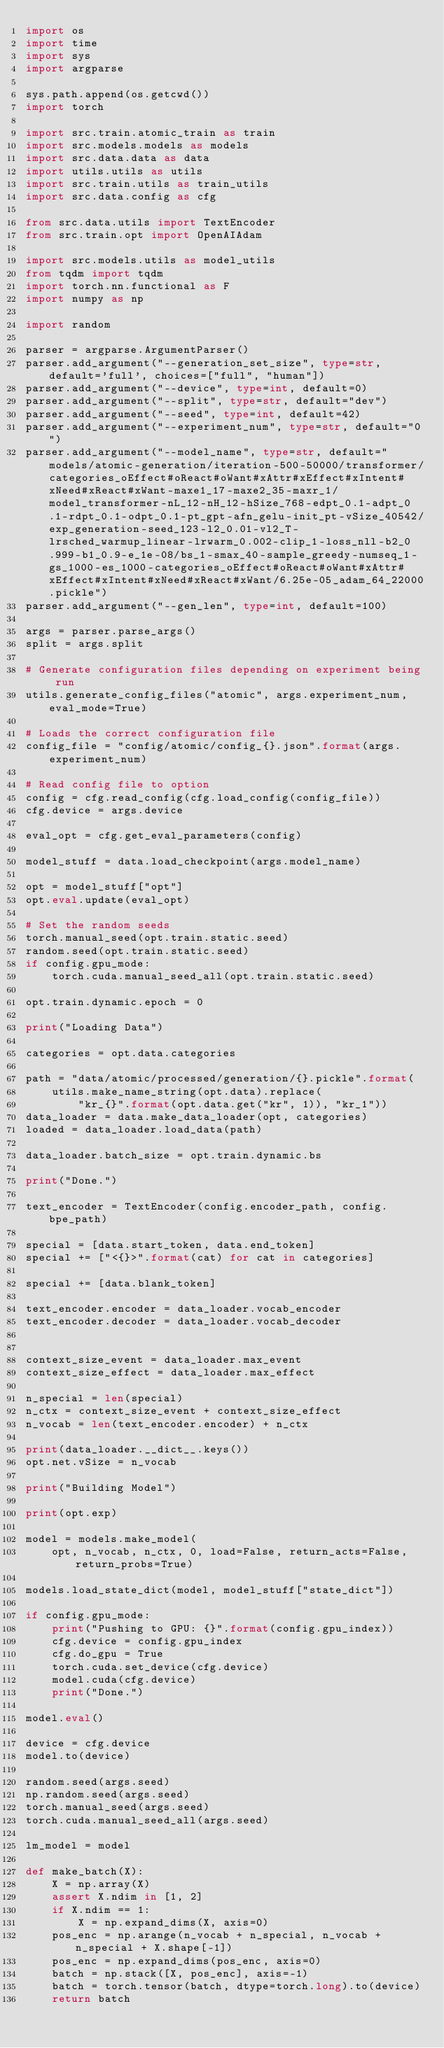<code> <loc_0><loc_0><loc_500><loc_500><_Python_>import os
import time
import sys
import argparse

sys.path.append(os.getcwd())
import torch

import src.train.atomic_train as train
import src.models.models as models
import src.data.data as data
import utils.utils as utils
import src.train.utils as train_utils
import src.data.config as cfg

from src.data.utils import TextEncoder
from src.train.opt import OpenAIAdam

import src.models.utils as model_utils
from tqdm import tqdm
import torch.nn.functional as F
import numpy as np

import random

parser = argparse.ArgumentParser()
parser.add_argument("--generation_set_size", type=str, default='full', choices=["full", "human"])
parser.add_argument("--device", type=int, default=0)
parser.add_argument("--split", type=str, default="dev")
parser.add_argument("--seed", type=int, default=42)
parser.add_argument("--experiment_num", type=str, default="0")
parser.add_argument("--model_name", type=str, default="models/atomic-generation/iteration-500-50000/transformer/categories_oEffect#oReact#oWant#xAttr#xEffect#xIntent#xNeed#xReact#xWant-maxe1_17-maxe2_35-maxr_1/model_transformer-nL_12-nH_12-hSize_768-edpt_0.1-adpt_0.1-rdpt_0.1-odpt_0.1-pt_gpt-afn_gelu-init_pt-vSize_40542/exp_generation-seed_123-l2_0.01-vl2_T-lrsched_warmup_linear-lrwarm_0.002-clip_1-loss_nll-b2_0.999-b1_0.9-e_1e-08/bs_1-smax_40-sample_greedy-numseq_1-gs_1000-es_1000-categories_oEffect#oReact#oWant#xAttr#xEffect#xIntent#xNeed#xReact#xWant/6.25e-05_adam_64_22000.pickle")
parser.add_argument("--gen_len", type=int, default=100)

args = parser.parse_args()
split = args.split

# Generate configuration files depending on experiment being run
utils.generate_config_files("atomic", args.experiment_num, eval_mode=True)

# Loads the correct configuration file
config_file = "config/atomic/config_{}.json".format(args.experiment_num)

# Read config file to option
config = cfg.read_config(cfg.load_config(config_file))
cfg.device = args.device

eval_opt = cfg.get_eval_parameters(config)

model_stuff = data.load_checkpoint(args.model_name)

opt = model_stuff["opt"]
opt.eval.update(eval_opt)

# Set the random seeds
torch.manual_seed(opt.train.static.seed)
random.seed(opt.train.static.seed)
if config.gpu_mode:
    torch.cuda.manual_seed_all(opt.train.static.seed)

opt.train.dynamic.epoch = 0

print("Loading Data")

categories = opt.data.categories

path = "data/atomic/processed/generation/{}.pickle".format(
    utils.make_name_string(opt.data).replace(
        "kr_{}".format(opt.data.get("kr", 1)), "kr_1"))
data_loader = data.make_data_loader(opt, categories)
loaded = data_loader.load_data(path)

data_loader.batch_size = opt.train.dynamic.bs

print("Done.")

text_encoder = TextEncoder(config.encoder_path, config.bpe_path)

special = [data.start_token, data.end_token]
special += ["<{}>".format(cat) for cat in categories]

special += [data.blank_token]

text_encoder.encoder = data_loader.vocab_encoder
text_encoder.decoder = data_loader.vocab_decoder


context_size_event = data_loader.max_event
context_size_effect = data_loader.max_effect

n_special = len(special)
n_ctx = context_size_event + context_size_effect
n_vocab = len(text_encoder.encoder) + n_ctx

print(data_loader.__dict__.keys())
opt.net.vSize = n_vocab

print("Building Model")

print(opt.exp)

model = models.make_model(
    opt, n_vocab, n_ctx, 0, load=False, return_acts=False, return_probs=True)

models.load_state_dict(model, model_stuff["state_dict"])

if config.gpu_mode:
    print("Pushing to GPU: {}".format(config.gpu_index))
    cfg.device = config.gpu_index
    cfg.do_gpu = True
    torch.cuda.set_device(cfg.device)
    model.cuda(cfg.device)
    print("Done.")

model.eval()

device = cfg.device
model.to(device)

random.seed(args.seed)
np.random.seed(args.seed)
torch.manual_seed(args.seed)
torch.cuda.manual_seed_all(args.seed)

lm_model = model

def make_batch(X):
    X = np.array(X)
    assert X.ndim in [1, 2]
    if X.ndim == 1:
        X = np.expand_dims(X, axis=0)
    pos_enc = np.arange(n_vocab + n_special, n_vocab + n_special + X.shape[-1])
    pos_enc = np.expand_dims(pos_enc, axis=0)
    batch = np.stack([X, pos_enc], axis=-1)
    batch = torch.tensor(batch, dtype=torch.long).to(device)
    return batch

</code> 